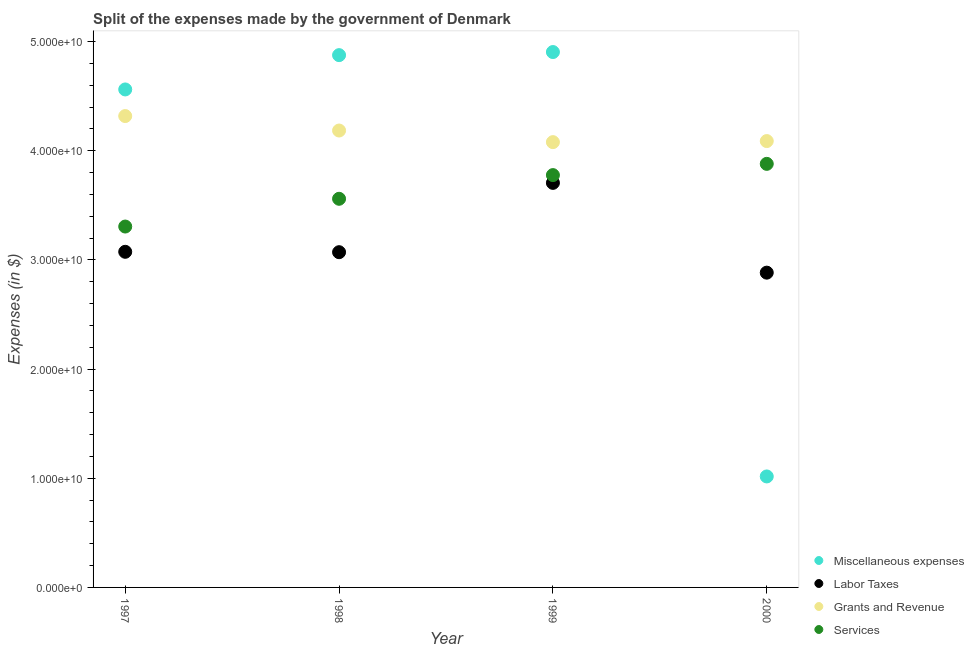How many different coloured dotlines are there?
Your response must be concise. 4. Is the number of dotlines equal to the number of legend labels?
Your answer should be very brief. Yes. What is the amount spent on grants and revenue in 1997?
Keep it short and to the point. 4.32e+1. Across all years, what is the maximum amount spent on services?
Your response must be concise. 3.88e+1. Across all years, what is the minimum amount spent on labor taxes?
Your response must be concise. 2.88e+1. In which year was the amount spent on services minimum?
Your answer should be very brief. 1997. What is the total amount spent on labor taxes in the graph?
Provide a short and direct response. 1.27e+11. What is the difference between the amount spent on miscellaneous expenses in 1999 and that in 2000?
Offer a terse response. 3.89e+1. What is the difference between the amount spent on grants and revenue in 1999 and the amount spent on services in 2000?
Make the answer very short. 1.99e+09. What is the average amount spent on miscellaneous expenses per year?
Make the answer very short. 3.84e+1. In the year 1997, what is the difference between the amount spent on miscellaneous expenses and amount spent on services?
Offer a terse response. 1.26e+1. In how many years, is the amount spent on labor taxes greater than 14000000000 $?
Your response must be concise. 4. What is the ratio of the amount spent on services in 1998 to that in 1999?
Provide a short and direct response. 0.94. What is the difference between the highest and the second highest amount spent on labor taxes?
Your answer should be compact. 6.31e+09. What is the difference between the highest and the lowest amount spent on miscellaneous expenses?
Ensure brevity in your answer.  3.89e+1. Is it the case that in every year, the sum of the amount spent on miscellaneous expenses and amount spent on labor taxes is greater than the amount spent on grants and revenue?
Provide a succinct answer. No. Is the amount spent on labor taxes strictly less than the amount spent on services over the years?
Your response must be concise. Yes. How many dotlines are there?
Your answer should be very brief. 4. How many years are there in the graph?
Make the answer very short. 4. What is the difference between two consecutive major ticks on the Y-axis?
Your answer should be compact. 1.00e+1. Does the graph contain any zero values?
Offer a terse response. No. Does the graph contain grids?
Keep it short and to the point. No. How are the legend labels stacked?
Your answer should be very brief. Vertical. What is the title of the graph?
Make the answer very short. Split of the expenses made by the government of Denmark. What is the label or title of the X-axis?
Give a very brief answer. Year. What is the label or title of the Y-axis?
Your answer should be compact. Expenses (in $). What is the Expenses (in $) of Miscellaneous expenses in 1997?
Your response must be concise. 4.56e+1. What is the Expenses (in $) of Labor Taxes in 1997?
Keep it short and to the point. 3.07e+1. What is the Expenses (in $) of Grants and Revenue in 1997?
Make the answer very short. 4.32e+1. What is the Expenses (in $) of Services in 1997?
Offer a terse response. 3.31e+1. What is the Expenses (in $) of Miscellaneous expenses in 1998?
Provide a succinct answer. 4.88e+1. What is the Expenses (in $) in Labor Taxes in 1998?
Provide a short and direct response. 3.07e+1. What is the Expenses (in $) of Grants and Revenue in 1998?
Keep it short and to the point. 4.19e+1. What is the Expenses (in $) in Services in 1998?
Your answer should be compact. 3.56e+1. What is the Expenses (in $) in Miscellaneous expenses in 1999?
Keep it short and to the point. 4.90e+1. What is the Expenses (in $) of Labor Taxes in 1999?
Make the answer very short. 3.71e+1. What is the Expenses (in $) in Grants and Revenue in 1999?
Keep it short and to the point. 4.08e+1. What is the Expenses (in $) of Services in 1999?
Offer a very short reply. 3.78e+1. What is the Expenses (in $) of Miscellaneous expenses in 2000?
Make the answer very short. 1.02e+1. What is the Expenses (in $) of Labor Taxes in 2000?
Make the answer very short. 2.88e+1. What is the Expenses (in $) in Grants and Revenue in 2000?
Offer a very short reply. 4.09e+1. What is the Expenses (in $) of Services in 2000?
Offer a terse response. 3.88e+1. Across all years, what is the maximum Expenses (in $) of Miscellaneous expenses?
Provide a succinct answer. 4.90e+1. Across all years, what is the maximum Expenses (in $) in Labor Taxes?
Make the answer very short. 3.71e+1. Across all years, what is the maximum Expenses (in $) in Grants and Revenue?
Provide a succinct answer. 4.32e+1. Across all years, what is the maximum Expenses (in $) in Services?
Ensure brevity in your answer.  3.88e+1. Across all years, what is the minimum Expenses (in $) of Miscellaneous expenses?
Keep it short and to the point. 1.02e+1. Across all years, what is the minimum Expenses (in $) in Labor Taxes?
Ensure brevity in your answer.  2.88e+1. Across all years, what is the minimum Expenses (in $) in Grants and Revenue?
Offer a terse response. 4.08e+1. Across all years, what is the minimum Expenses (in $) in Services?
Your answer should be very brief. 3.31e+1. What is the total Expenses (in $) in Miscellaneous expenses in the graph?
Your answer should be compact. 1.54e+11. What is the total Expenses (in $) of Labor Taxes in the graph?
Offer a terse response. 1.27e+11. What is the total Expenses (in $) in Grants and Revenue in the graph?
Keep it short and to the point. 1.67e+11. What is the total Expenses (in $) in Services in the graph?
Your answer should be very brief. 1.45e+11. What is the difference between the Expenses (in $) in Miscellaneous expenses in 1997 and that in 1998?
Offer a very short reply. -3.14e+09. What is the difference between the Expenses (in $) of Labor Taxes in 1997 and that in 1998?
Provide a short and direct response. 3.50e+07. What is the difference between the Expenses (in $) in Grants and Revenue in 1997 and that in 1998?
Offer a terse response. 1.33e+09. What is the difference between the Expenses (in $) of Services in 1997 and that in 1998?
Give a very brief answer. -2.54e+09. What is the difference between the Expenses (in $) of Miscellaneous expenses in 1997 and that in 1999?
Your response must be concise. -3.43e+09. What is the difference between the Expenses (in $) in Labor Taxes in 1997 and that in 1999?
Make the answer very short. -6.31e+09. What is the difference between the Expenses (in $) of Grants and Revenue in 1997 and that in 1999?
Keep it short and to the point. 2.39e+09. What is the difference between the Expenses (in $) in Services in 1997 and that in 1999?
Keep it short and to the point. -4.71e+09. What is the difference between the Expenses (in $) of Miscellaneous expenses in 1997 and that in 2000?
Offer a terse response. 3.55e+1. What is the difference between the Expenses (in $) of Labor Taxes in 1997 and that in 2000?
Your answer should be compact. 1.91e+09. What is the difference between the Expenses (in $) of Grants and Revenue in 1997 and that in 2000?
Make the answer very short. 2.29e+09. What is the difference between the Expenses (in $) in Services in 1997 and that in 2000?
Keep it short and to the point. -5.74e+09. What is the difference between the Expenses (in $) in Miscellaneous expenses in 1998 and that in 1999?
Your answer should be compact. -2.83e+08. What is the difference between the Expenses (in $) in Labor Taxes in 1998 and that in 1999?
Your answer should be very brief. -6.35e+09. What is the difference between the Expenses (in $) of Grants and Revenue in 1998 and that in 1999?
Keep it short and to the point. 1.06e+09. What is the difference between the Expenses (in $) of Services in 1998 and that in 1999?
Your answer should be very brief. -2.17e+09. What is the difference between the Expenses (in $) in Miscellaneous expenses in 1998 and that in 2000?
Give a very brief answer. 3.86e+1. What is the difference between the Expenses (in $) of Labor Taxes in 1998 and that in 2000?
Provide a succinct answer. 1.88e+09. What is the difference between the Expenses (in $) of Grants and Revenue in 1998 and that in 2000?
Make the answer very short. 9.66e+08. What is the difference between the Expenses (in $) of Services in 1998 and that in 2000?
Offer a terse response. -3.20e+09. What is the difference between the Expenses (in $) in Miscellaneous expenses in 1999 and that in 2000?
Ensure brevity in your answer.  3.89e+1. What is the difference between the Expenses (in $) of Labor Taxes in 1999 and that in 2000?
Provide a succinct answer. 8.22e+09. What is the difference between the Expenses (in $) of Grants and Revenue in 1999 and that in 2000?
Give a very brief answer. -9.70e+07. What is the difference between the Expenses (in $) of Services in 1999 and that in 2000?
Keep it short and to the point. -1.03e+09. What is the difference between the Expenses (in $) in Miscellaneous expenses in 1997 and the Expenses (in $) in Labor Taxes in 1998?
Make the answer very short. 1.49e+1. What is the difference between the Expenses (in $) in Miscellaneous expenses in 1997 and the Expenses (in $) in Grants and Revenue in 1998?
Provide a short and direct response. 3.76e+09. What is the difference between the Expenses (in $) of Miscellaneous expenses in 1997 and the Expenses (in $) of Services in 1998?
Offer a terse response. 1.00e+1. What is the difference between the Expenses (in $) of Labor Taxes in 1997 and the Expenses (in $) of Grants and Revenue in 1998?
Offer a very short reply. -1.11e+1. What is the difference between the Expenses (in $) of Labor Taxes in 1997 and the Expenses (in $) of Services in 1998?
Offer a very short reply. -4.86e+09. What is the difference between the Expenses (in $) in Grants and Revenue in 1997 and the Expenses (in $) in Services in 1998?
Give a very brief answer. 7.58e+09. What is the difference between the Expenses (in $) of Miscellaneous expenses in 1997 and the Expenses (in $) of Labor Taxes in 1999?
Offer a terse response. 8.56e+09. What is the difference between the Expenses (in $) in Miscellaneous expenses in 1997 and the Expenses (in $) in Grants and Revenue in 1999?
Provide a short and direct response. 4.83e+09. What is the difference between the Expenses (in $) in Miscellaneous expenses in 1997 and the Expenses (in $) in Services in 1999?
Give a very brief answer. 7.85e+09. What is the difference between the Expenses (in $) of Labor Taxes in 1997 and the Expenses (in $) of Grants and Revenue in 1999?
Offer a very short reply. -1.00e+1. What is the difference between the Expenses (in $) of Labor Taxes in 1997 and the Expenses (in $) of Services in 1999?
Make the answer very short. -7.03e+09. What is the difference between the Expenses (in $) of Grants and Revenue in 1997 and the Expenses (in $) of Services in 1999?
Give a very brief answer. 5.41e+09. What is the difference between the Expenses (in $) in Miscellaneous expenses in 1997 and the Expenses (in $) in Labor Taxes in 2000?
Provide a succinct answer. 1.68e+1. What is the difference between the Expenses (in $) in Miscellaneous expenses in 1997 and the Expenses (in $) in Grants and Revenue in 2000?
Your answer should be very brief. 4.73e+09. What is the difference between the Expenses (in $) in Miscellaneous expenses in 1997 and the Expenses (in $) in Services in 2000?
Your response must be concise. 6.82e+09. What is the difference between the Expenses (in $) of Labor Taxes in 1997 and the Expenses (in $) of Grants and Revenue in 2000?
Keep it short and to the point. -1.01e+1. What is the difference between the Expenses (in $) of Labor Taxes in 1997 and the Expenses (in $) of Services in 2000?
Give a very brief answer. -8.06e+09. What is the difference between the Expenses (in $) in Grants and Revenue in 1997 and the Expenses (in $) in Services in 2000?
Give a very brief answer. 4.38e+09. What is the difference between the Expenses (in $) of Miscellaneous expenses in 1998 and the Expenses (in $) of Labor Taxes in 1999?
Make the answer very short. 1.17e+1. What is the difference between the Expenses (in $) in Miscellaneous expenses in 1998 and the Expenses (in $) in Grants and Revenue in 1999?
Give a very brief answer. 7.97e+09. What is the difference between the Expenses (in $) of Miscellaneous expenses in 1998 and the Expenses (in $) of Services in 1999?
Make the answer very short. 1.10e+1. What is the difference between the Expenses (in $) of Labor Taxes in 1998 and the Expenses (in $) of Grants and Revenue in 1999?
Keep it short and to the point. -1.01e+1. What is the difference between the Expenses (in $) in Labor Taxes in 1998 and the Expenses (in $) in Services in 1999?
Offer a very short reply. -7.06e+09. What is the difference between the Expenses (in $) of Grants and Revenue in 1998 and the Expenses (in $) of Services in 1999?
Provide a succinct answer. 4.08e+09. What is the difference between the Expenses (in $) of Miscellaneous expenses in 1998 and the Expenses (in $) of Labor Taxes in 2000?
Give a very brief answer. 1.99e+1. What is the difference between the Expenses (in $) in Miscellaneous expenses in 1998 and the Expenses (in $) in Grants and Revenue in 2000?
Keep it short and to the point. 7.87e+09. What is the difference between the Expenses (in $) of Miscellaneous expenses in 1998 and the Expenses (in $) of Services in 2000?
Keep it short and to the point. 9.96e+09. What is the difference between the Expenses (in $) in Labor Taxes in 1998 and the Expenses (in $) in Grants and Revenue in 2000?
Give a very brief answer. -1.02e+1. What is the difference between the Expenses (in $) of Labor Taxes in 1998 and the Expenses (in $) of Services in 2000?
Keep it short and to the point. -8.09e+09. What is the difference between the Expenses (in $) in Grants and Revenue in 1998 and the Expenses (in $) in Services in 2000?
Provide a short and direct response. 3.05e+09. What is the difference between the Expenses (in $) of Miscellaneous expenses in 1999 and the Expenses (in $) of Labor Taxes in 2000?
Your response must be concise. 2.02e+1. What is the difference between the Expenses (in $) in Miscellaneous expenses in 1999 and the Expenses (in $) in Grants and Revenue in 2000?
Ensure brevity in your answer.  8.16e+09. What is the difference between the Expenses (in $) in Miscellaneous expenses in 1999 and the Expenses (in $) in Services in 2000?
Keep it short and to the point. 1.02e+1. What is the difference between the Expenses (in $) in Labor Taxes in 1999 and the Expenses (in $) in Grants and Revenue in 2000?
Offer a terse response. -3.83e+09. What is the difference between the Expenses (in $) of Labor Taxes in 1999 and the Expenses (in $) of Services in 2000?
Keep it short and to the point. -1.74e+09. What is the difference between the Expenses (in $) of Grants and Revenue in 1999 and the Expenses (in $) of Services in 2000?
Make the answer very short. 1.99e+09. What is the average Expenses (in $) in Miscellaneous expenses per year?
Offer a terse response. 3.84e+1. What is the average Expenses (in $) in Labor Taxes per year?
Provide a succinct answer. 3.18e+1. What is the average Expenses (in $) in Grants and Revenue per year?
Offer a very short reply. 4.17e+1. What is the average Expenses (in $) of Services per year?
Keep it short and to the point. 3.63e+1. In the year 1997, what is the difference between the Expenses (in $) in Miscellaneous expenses and Expenses (in $) in Labor Taxes?
Provide a succinct answer. 1.49e+1. In the year 1997, what is the difference between the Expenses (in $) of Miscellaneous expenses and Expenses (in $) of Grants and Revenue?
Provide a short and direct response. 2.44e+09. In the year 1997, what is the difference between the Expenses (in $) of Miscellaneous expenses and Expenses (in $) of Services?
Your response must be concise. 1.26e+1. In the year 1997, what is the difference between the Expenses (in $) in Labor Taxes and Expenses (in $) in Grants and Revenue?
Provide a succinct answer. -1.24e+1. In the year 1997, what is the difference between the Expenses (in $) of Labor Taxes and Expenses (in $) of Services?
Keep it short and to the point. -2.31e+09. In the year 1997, what is the difference between the Expenses (in $) of Grants and Revenue and Expenses (in $) of Services?
Your answer should be very brief. 1.01e+1. In the year 1998, what is the difference between the Expenses (in $) in Miscellaneous expenses and Expenses (in $) in Labor Taxes?
Your answer should be very brief. 1.81e+1. In the year 1998, what is the difference between the Expenses (in $) in Miscellaneous expenses and Expenses (in $) in Grants and Revenue?
Ensure brevity in your answer.  6.91e+09. In the year 1998, what is the difference between the Expenses (in $) of Miscellaneous expenses and Expenses (in $) of Services?
Your answer should be compact. 1.32e+1. In the year 1998, what is the difference between the Expenses (in $) in Labor Taxes and Expenses (in $) in Grants and Revenue?
Offer a very short reply. -1.11e+1. In the year 1998, what is the difference between the Expenses (in $) in Labor Taxes and Expenses (in $) in Services?
Your answer should be compact. -4.89e+09. In the year 1998, what is the difference between the Expenses (in $) of Grants and Revenue and Expenses (in $) of Services?
Give a very brief answer. 6.25e+09. In the year 1999, what is the difference between the Expenses (in $) in Miscellaneous expenses and Expenses (in $) in Labor Taxes?
Your answer should be very brief. 1.20e+1. In the year 1999, what is the difference between the Expenses (in $) of Miscellaneous expenses and Expenses (in $) of Grants and Revenue?
Offer a very short reply. 8.25e+09. In the year 1999, what is the difference between the Expenses (in $) of Miscellaneous expenses and Expenses (in $) of Services?
Provide a succinct answer. 1.13e+1. In the year 1999, what is the difference between the Expenses (in $) in Labor Taxes and Expenses (in $) in Grants and Revenue?
Offer a very short reply. -3.73e+09. In the year 1999, what is the difference between the Expenses (in $) of Labor Taxes and Expenses (in $) of Services?
Provide a short and direct response. -7.13e+08. In the year 1999, what is the difference between the Expenses (in $) of Grants and Revenue and Expenses (in $) of Services?
Your answer should be compact. 3.02e+09. In the year 2000, what is the difference between the Expenses (in $) of Miscellaneous expenses and Expenses (in $) of Labor Taxes?
Give a very brief answer. -1.87e+1. In the year 2000, what is the difference between the Expenses (in $) of Miscellaneous expenses and Expenses (in $) of Grants and Revenue?
Your response must be concise. -3.07e+1. In the year 2000, what is the difference between the Expenses (in $) in Miscellaneous expenses and Expenses (in $) in Services?
Provide a succinct answer. -2.86e+1. In the year 2000, what is the difference between the Expenses (in $) in Labor Taxes and Expenses (in $) in Grants and Revenue?
Offer a very short reply. -1.21e+1. In the year 2000, what is the difference between the Expenses (in $) of Labor Taxes and Expenses (in $) of Services?
Keep it short and to the point. -9.97e+09. In the year 2000, what is the difference between the Expenses (in $) of Grants and Revenue and Expenses (in $) of Services?
Give a very brief answer. 2.09e+09. What is the ratio of the Expenses (in $) in Miscellaneous expenses in 1997 to that in 1998?
Provide a short and direct response. 0.94. What is the ratio of the Expenses (in $) of Labor Taxes in 1997 to that in 1998?
Provide a succinct answer. 1. What is the ratio of the Expenses (in $) of Grants and Revenue in 1997 to that in 1998?
Provide a short and direct response. 1.03. What is the ratio of the Expenses (in $) in Services in 1997 to that in 1998?
Make the answer very short. 0.93. What is the ratio of the Expenses (in $) of Miscellaneous expenses in 1997 to that in 1999?
Keep it short and to the point. 0.93. What is the ratio of the Expenses (in $) of Labor Taxes in 1997 to that in 1999?
Keep it short and to the point. 0.83. What is the ratio of the Expenses (in $) in Grants and Revenue in 1997 to that in 1999?
Give a very brief answer. 1.06. What is the ratio of the Expenses (in $) of Services in 1997 to that in 1999?
Provide a short and direct response. 0.88. What is the ratio of the Expenses (in $) in Miscellaneous expenses in 1997 to that in 2000?
Offer a very short reply. 4.49. What is the ratio of the Expenses (in $) of Labor Taxes in 1997 to that in 2000?
Offer a terse response. 1.07. What is the ratio of the Expenses (in $) in Grants and Revenue in 1997 to that in 2000?
Provide a succinct answer. 1.06. What is the ratio of the Expenses (in $) of Services in 1997 to that in 2000?
Provide a short and direct response. 0.85. What is the ratio of the Expenses (in $) of Miscellaneous expenses in 1998 to that in 1999?
Make the answer very short. 0.99. What is the ratio of the Expenses (in $) in Labor Taxes in 1998 to that in 1999?
Keep it short and to the point. 0.83. What is the ratio of the Expenses (in $) in Grants and Revenue in 1998 to that in 1999?
Make the answer very short. 1.03. What is the ratio of the Expenses (in $) in Services in 1998 to that in 1999?
Your answer should be very brief. 0.94. What is the ratio of the Expenses (in $) of Miscellaneous expenses in 1998 to that in 2000?
Offer a terse response. 4.8. What is the ratio of the Expenses (in $) of Labor Taxes in 1998 to that in 2000?
Your answer should be compact. 1.06. What is the ratio of the Expenses (in $) of Grants and Revenue in 1998 to that in 2000?
Offer a terse response. 1.02. What is the ratio of the Expenses (in $) in Services in 1998 to that in 2000?
Offer a very short reply. 0.92. What is the ratio of the Expenses (in $) of Miscellaneous expenses in 1999 to that in 2000?
Offer a very short reply. 4.82. What is the ratio of the Expenses (in $) in Labor Taxes in 1999 to that in 2000?
Provide a short and direct response. 1.29. What is the ratio of the Expenses (in $) in Services in 1999 to that in 2000?
Provide a succinct answer. 0.97. What is the difference between the highest and the second highest Expenses (in $) in Miscellaneous expenses?
Your response must be concise. 2.83e+08. What is the difference between the highest and the second highest Expenses (in $) of Labor Taxes?
Offer a terse response. 6.31e+09. What is the difference between the highest and the second highest Expenses (in $) of Grants and Revenue?
Offer a terse response. 1.33e+09. What is the difference between the highest and the second highest Expenses (in $) of Services?
Provide a short and direct response. 1.03e+09. What is the difference between the highest and the lowest Expenses (in $) in Miscellaneous expenses?
Provide a succinct answer. 3.89e+1. What is the difference between the highest and the lowest Expenses (in $) of Labor Taxes?
Your answer should be very brief. 8.22e+09. What is the difference between the highest and the lowest Expenses (in $) in Grants and Revenue?
Your answer should be compact. 2.39e+09. What is the difference between the highest and the lowest Expenses (in $) in Services?
Your answer should be compact. 5.74e+09. 